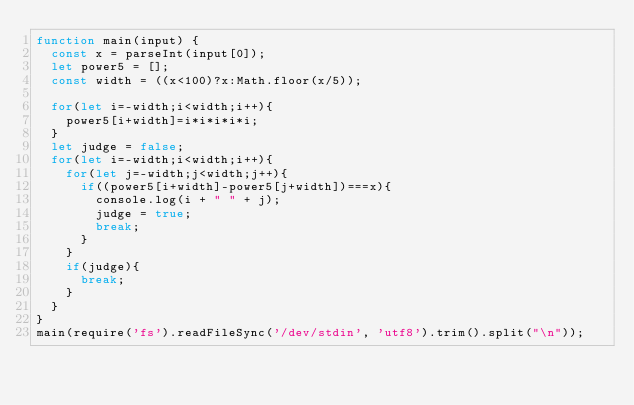Convert code to text. <code><loc_0><loc_0><loc_500><loc_500><_JavaScript_>function main(input) {
  const x = parseInt(input[0]);
  let power5 = [];
  const width = ((x<100)?x:Math.floor(x/5));

  for(let i=-width;i<width;i++){
    power5[i+width]=i*i*i*i*i;
  }
  let judge = false;
  for(let i=-width;i<width;i++){
    for(let j=-width;j<width;j++){
      if((power5[i+width]-power5[j+width])===x){
        console.log(i + " " + j);
        judge = true;
        break;
      }
    }
    if(judge){
      break;
    }
  }
}
main(require('fs').readFileSync('/dev/stdin', 'utf8').trim().split("\n"));</code> 